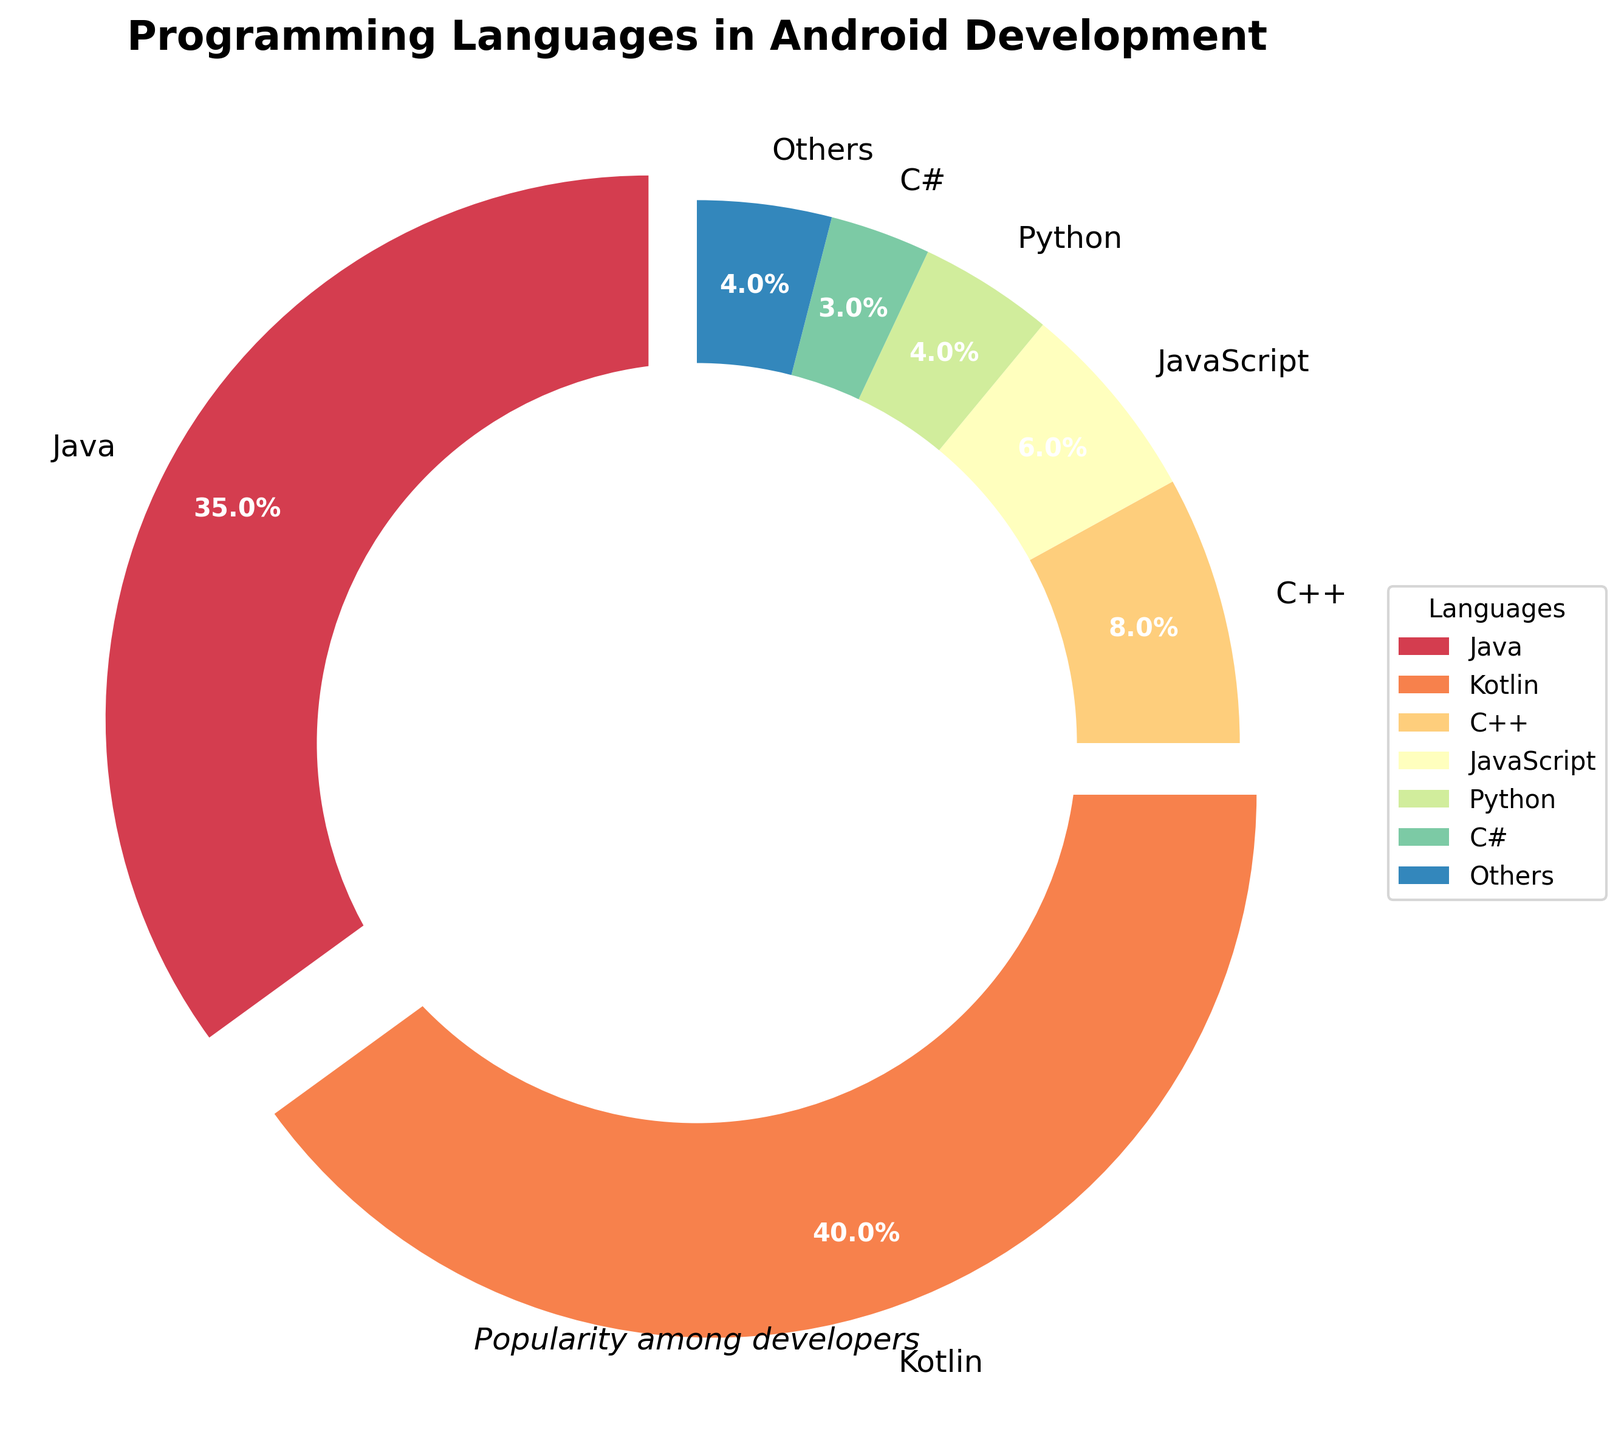Which programming language has the highest popularity among Android developers? The pie chart clearly shows that Kotlin has the largest proportion, highlighted with a segment that slightly 'explodes' to emphasize its significance.
Answer: Kotlin What is the combined percentage of Java and Kotlin in the chart? The percentage for Java is 35% and for Kotlin is 40%. Adding them together gives 35% + 40% = 75%.
Answer: 75% Between Java and Kotlin, which has a higher percentage and by how much? Comparing the segments, Kotlin (40%) has a higher percentage than Java (35%). The difference is 40% - 35% = 5%.
Answer: Kotlin by 5% What is the combined percentage of all languages, excluding the 'Others' category? Summing up the shown percentages: Java (35%) + Kotlin (40%) + C++ (8%) + JavaScript (6%) + Python (4%) + C# (3%) = 96%. This means 'Others' account for the remaining 4%.
Answer: 96% What visual cues are used in the chart to emphasize the most popular languages? The chart uses an 'exploding' effect on key segments to highlight their significance. Java and Kotlin segments are slightly separated from the rest of the pie to draw attention.
Answer: Exploding effect How does the size of the C++ segment compare to the JavaScript segment? The chart shows C++ at 8% and JavaScript at 6%. The C++ segment is larger than the JavaScript segment.
Answer: C++ > JavaScript Which category includes some of the least popular languages and what is the total percentage of this category? The 'Others' category combines languages with individual percentages less than 3% (Scala, Dart, Lua, Ruby). Together with any aggregated small segments, it forms the 'Others' segment.
Answer: Others (4%) How much more popular is Kotlin compared to Python? Kotlin is 40%, while Python is 4%. The difference is 40% - 4% = 36%.
Answer: 36% What is the total percentage of programming languages included in the 'Others' category if languages like Scala, Dart, Lua, and Ruby are added? The total percentage occupied by 'Others' in the chart accounts for any remaining percentage after summing the listed languages. Since the visible languages account for 96%, 'Others' makes up 100% - 96% = 4%.
Answer: 4% 